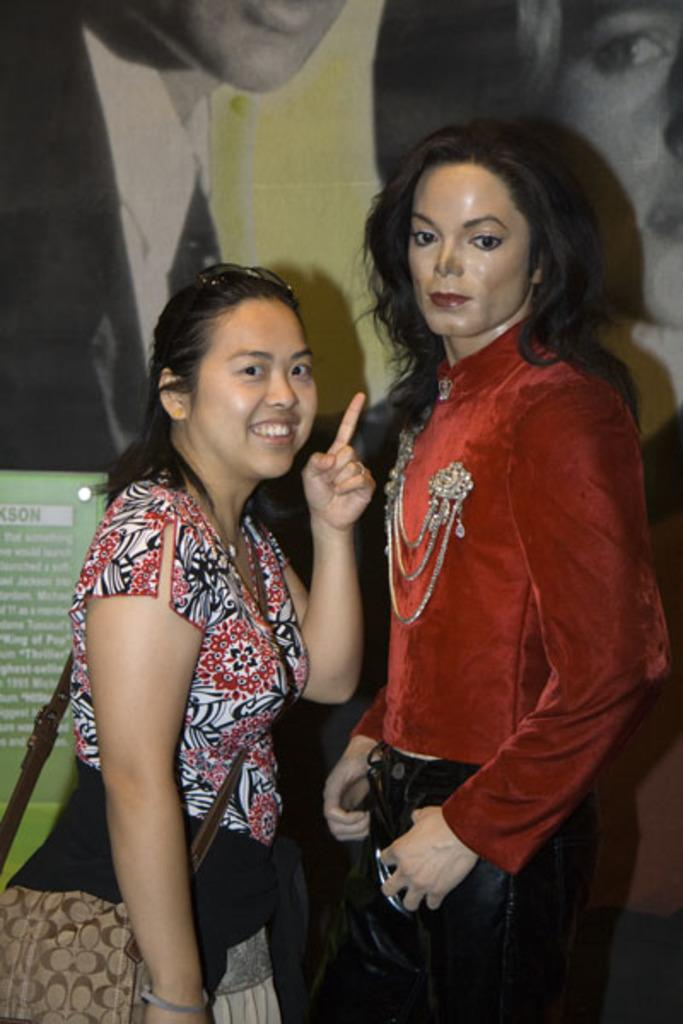What is the main subject in the image? There is a statue in the image. What else can be seen in the image besides the statue? There is a woman in the image. Can you describe the woman's appearance? The woman is wearing a bag and smiling. What is visible in the background of the image? There are pictures of people and a board in the background of the image. What type of slope can be seen in the image? There is no slope present in the image. How does the woman's health appear to be in the image? The woman's health cannot be determined from the image, as there is no information about her health provided. 